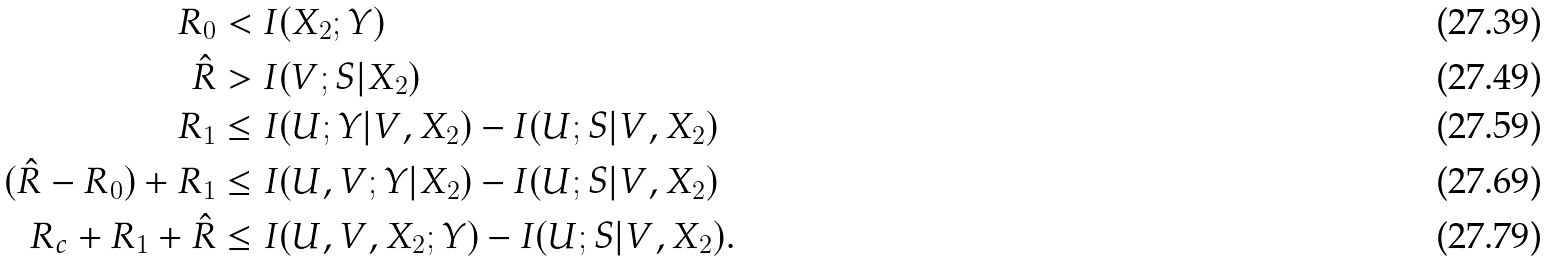Convert formula to latex. <formula><loc_0><loc_0><loc_500><loc_500>R _ { 0 } & < I ( X _ { 2 } ; Y ) \\ \hat { R } & > I ( V ; S | X _ { 2 } ) \\ R _ { 1 } & \leq I ( U ; Y | V , X _ { 2 } ) - I ( U ; S | V , X _ { 2 } ) \\ ( \hat { R } - R _ { 0 } ) + R _ { 1 } & \leq I ( U , V ; Y | X _ { 2 } ) - I ( U ; S | V , X _ { 2 } ) \\ R _ { c } + R _ { 1 } + \hat { R } & \leq I ( U , V , X _ { 2 } ; Y ) - I ( U ; S | V , X _ { 2 } ) .</formula> 